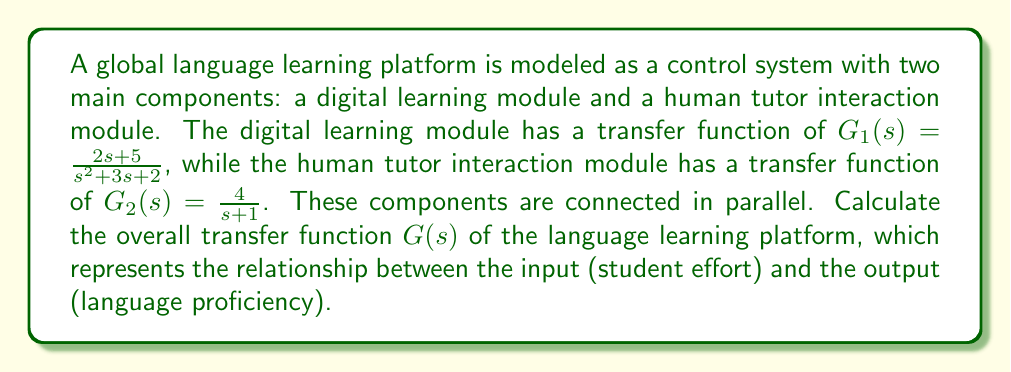Can you solve this math problem? To solve this problem, we need to follow these steps:

1. Recall that for parallel connections in control systems, the overall transfer function is the sum of the individual transfer functions.

2. The overall transfer function $G(s)$ is given by:

   $G(s) = G_1(s) + G_2(s)$

3. Substitute the given transfer functions:

   $G(s) = \frac{2s+5}{s^2+3s+2} + \frac{4}{s+1}$

4. To add these fractions, we need a common denominator. The least common multiple of the denominators is $(s^2+3s+2)(s+1)$:

   $G(s) = \frac{(2s+5)(s+1)}{(s^2+3s+2)(s+1)} + \frac{4(s^2+3s+2)}{(s^2+3s+2)(s+1)}$

5. Expand the numerators:

   $G(s) = \frac{2s^2+7s+5}{(s^2+3s+2)(s+1)} + \frac{4s^2+12s+8}{(s^2+3s+2)(s+1)}$

6. Add the numerators:

   $G(s) = \frac{2s^2+7s+5 + 4s^2+12s+8}{(s^2+3s+2)(s+1)}$

7. Simplify the numerator:

   $G(s) = \frac{6s^2+19s+13}{(s^2+3s+2)(s+1)}$

8. Expand the denominator:

   $G(s) = \frac{6s^2+19s+13}{s^3+4s^2+5s+2}$

This is the final form of the overall transfer function for the global language learning platform.
Answer: $G(s) = \frac{6s^2+19s+13}{s^3+4s^2+5s+2}$ 